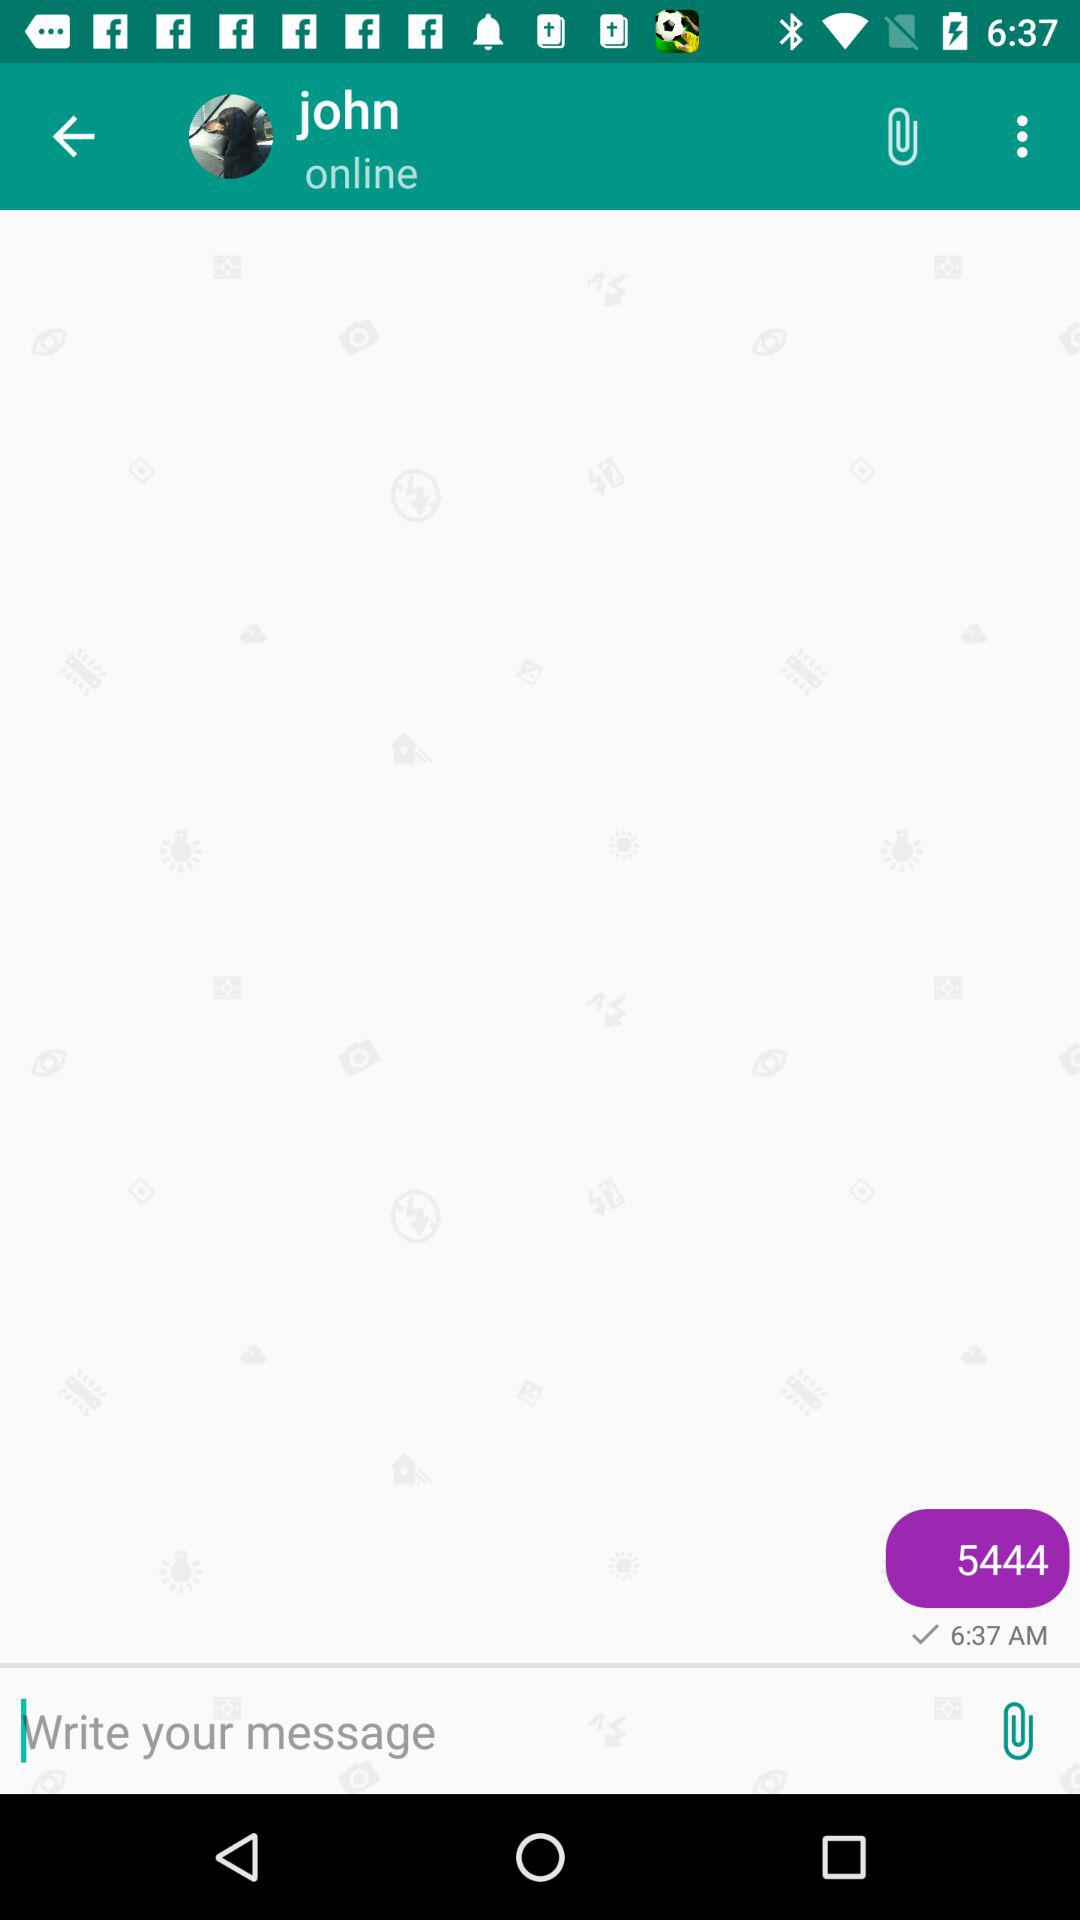What's the current status of John? John is currently online. 